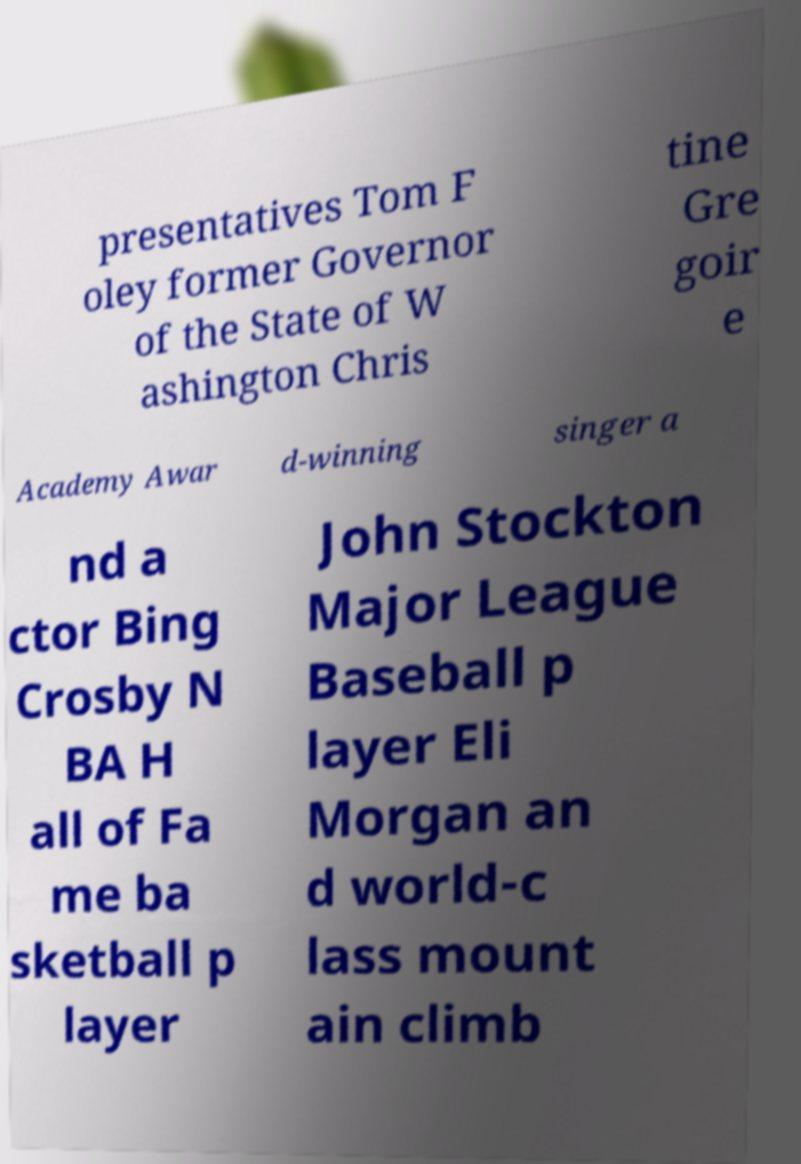There's text embedded in this image that I need extracted. Can you transcribe it verbatim? presentatives Tom F oley former Governor of the State of W ashington Chris tine Gre goir e Academy Awar d-winning singer a nd a ctor Bing Crosby N BA H all of Fa me ba sketball p layer John Stockton Major League Baseball p layer Eli Morgan an d world-c lass mount ain climb 